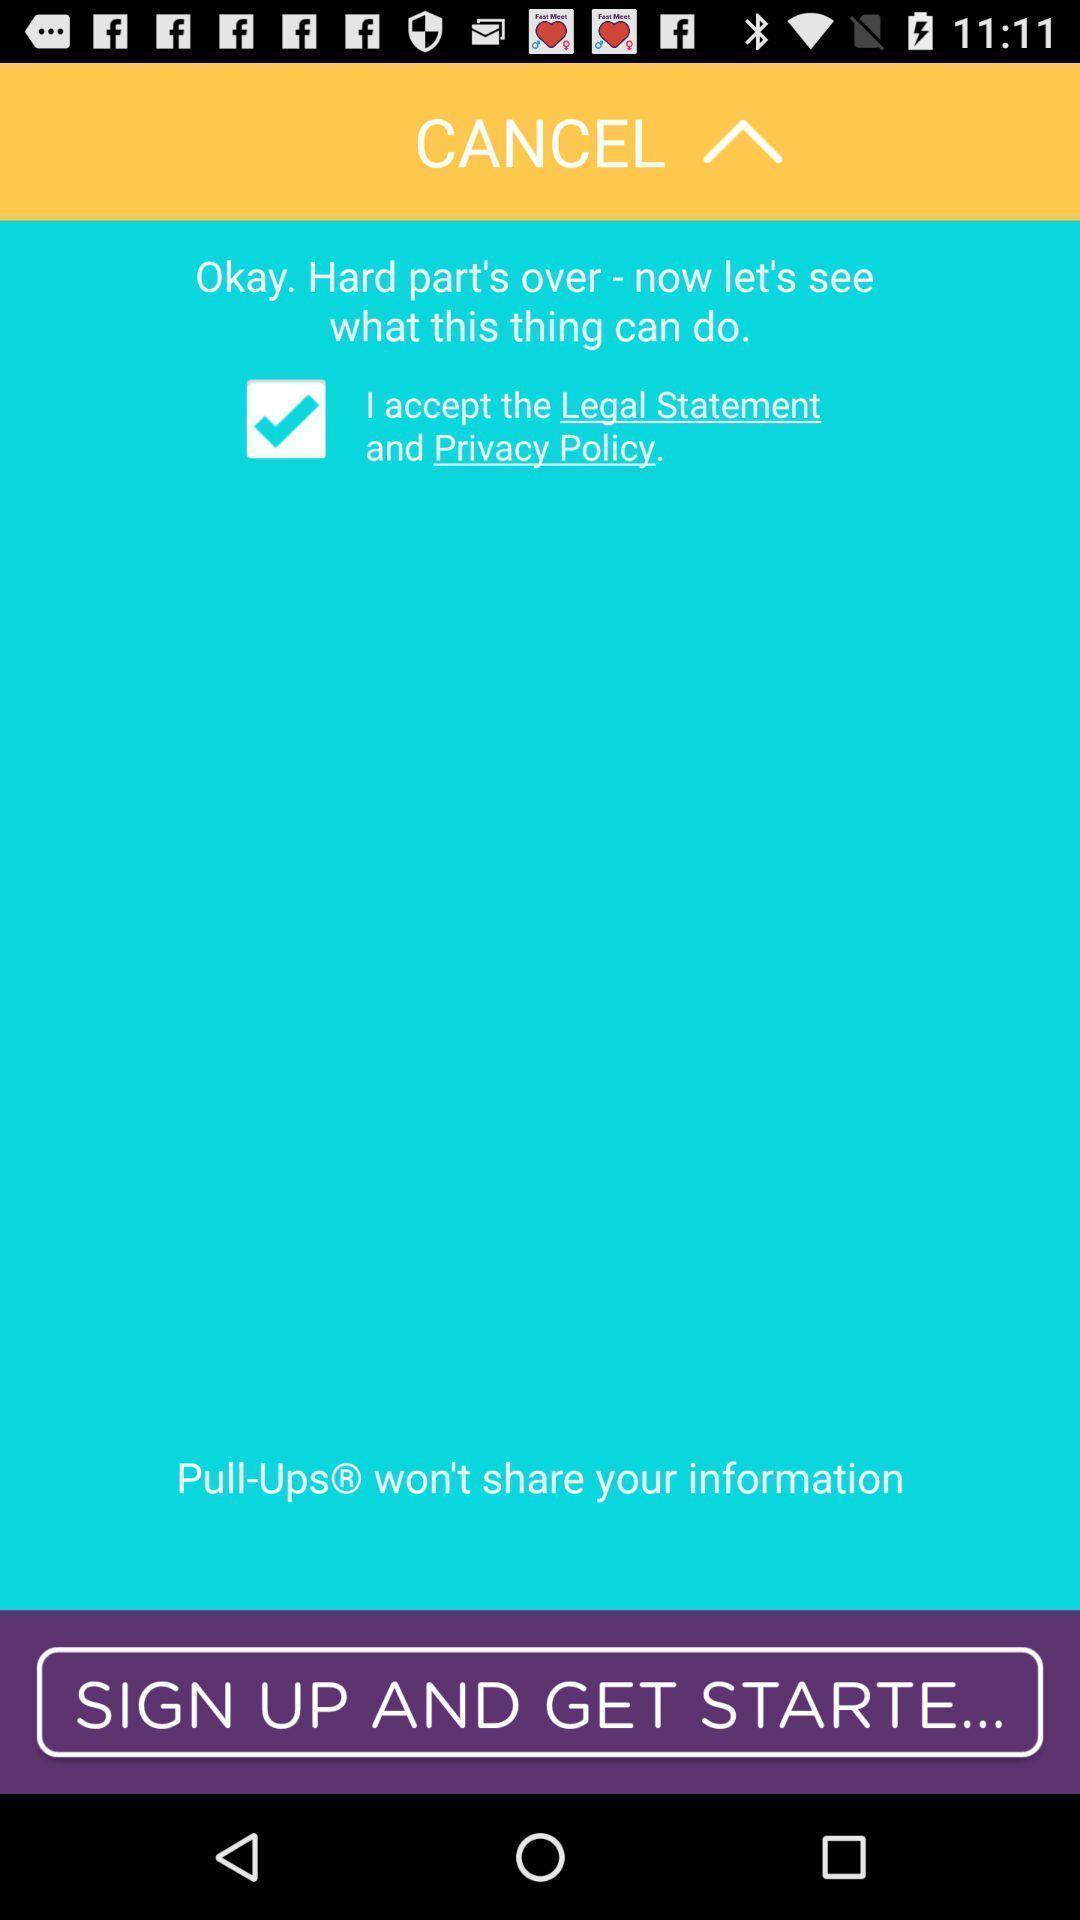Describe the key features of this screenshot. Sign up page for an application. 